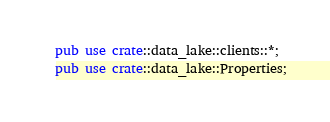<code> <loc_0><loc_0><loc_500><loc_500><_Rust_>pub use crate::data_lake::clients::*;
pub use crate::data_lake::Properties;
</code> 